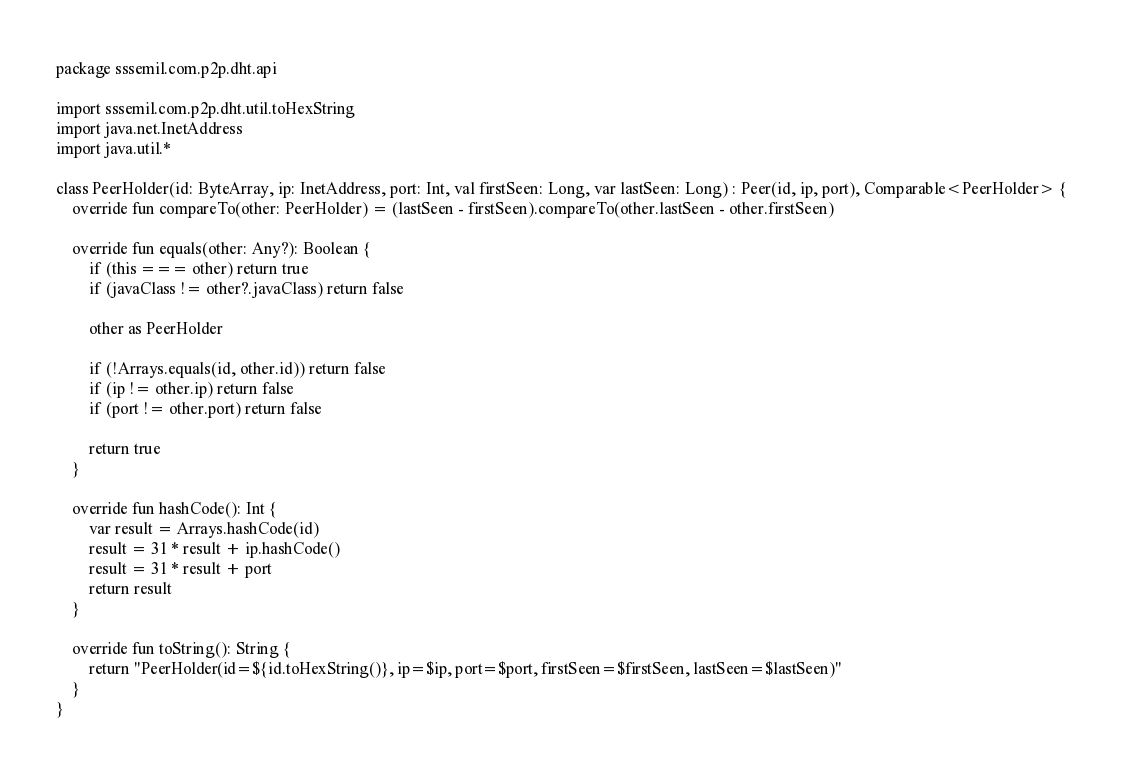Convert code to text. <code><loc_0><loc_0><loc_500><loc_500><_Kotlin_>package sssemil.com.p2p.dht.api

import sssemil.com.p2p.dht.util.toHexString
import java.net.InetAddress
import java.util.*

class PeerHolder(id: ByteArray, ip: InetAddress, port: Int, val firstSeen: Long, var lastSeen: Long) : Peer(id, ip, port), Comparable<PeerHolder> {
    override fun compareTo(other: PeerHolder) = (lastSeen - firstSeen).compareTo(other.lastSeen - other.firstSeen)

    override fun equals(other: Any?): Boolean {
        if (this === other) return true
        if (javaClass != other?.javaClass) return false

        other as PeerHolder

        if (!Arrays.equals(id, other.id)) return false
        if (ip != other.ip) return false
        if (port != other.port) return false

        return true
    }

    override fun hashCode(): Int {
        var result = Arrays.hashCode(id)
        result = 31 * result + ip.hashCode()
        result = 31 * result + port
        return result
    }

    override fun toString(): String {
        return "PeerHolder(id=${id.toHexString()}, ip=$ip, port=$port, firstSeen=$firstSeen, lastSeen=$lastSeen)"
    }
}</code> 